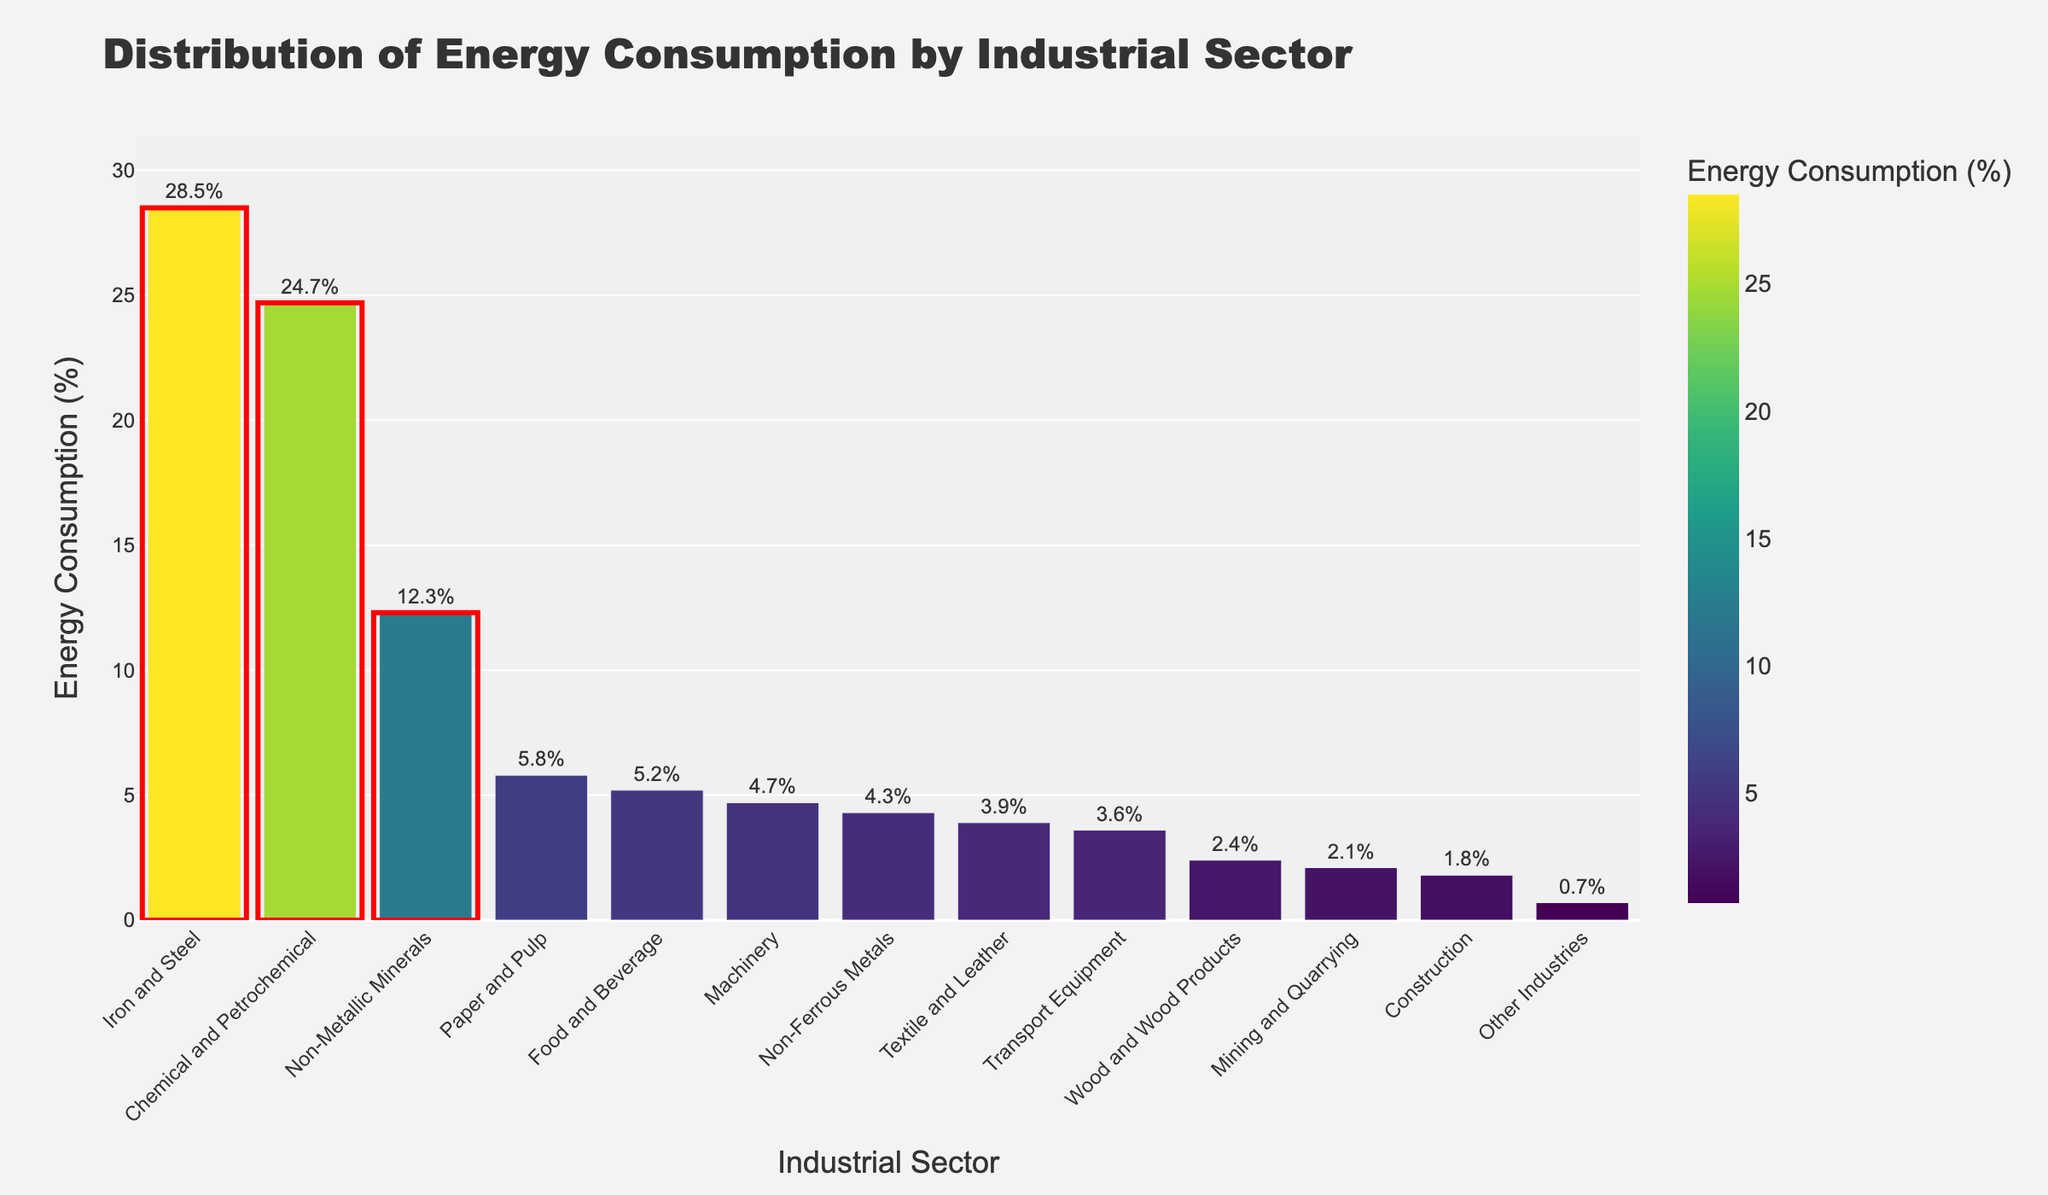What sector has the highest energy consumption? The figure highlights sectors in different colors and shows their energy consumption as percentages. The sector with the tallest bar and highest percentage is the Iron and Steel sector.
Answer: Iron and Steel What is the combined energy consumption percentage of the top three sectors? The top three sectors by energy consumption percentage are Iron and Steel (28.5%), Chemical and Petrochemical (24.7%), and Non-Metallic Minerals (12.3%). Adding these percentages gives their combined energy consumption: 28.5 + 24.7 + 12.3 = 65.5%.
Answer: 65.5% How does the energy consumption of the Food and Beverage sector compare to that of the Paper and Pulp sector? Comparing the heights of the bars for Food and Beverage (5.2%) and Paper and Pulp (5.8%) shows that Paper and Pulp has a slightly higher energy consumption percentage than Food and Beverage.
Answer: Paper and Pulp is higher What is the energy consumption difference between Machinery and Textile and Leather sectors? Referring to the chart, the energy consumption of Machinery is 4.7% and that of Textile and Leather is 3.9%. The difference is calculated as 4.7 - 3.9 = 0.8%.
Answer: 0.8% What sector has the least energy consumption, and what is its percentage? The sector with the shortest bar and the lowest energy consumption percentage is Other Industries, with a consumption percentage of 0.7%.
Answer: Other Industries, 0.7% Which sector is highlighted with a red outline in the chart? The red outlines highlight the top three sectors with the highest energy consumption percentages: Iron and Steel, Chemical and Petrochemical, and Non-Metallic Minerals.
Answer: Iron and Steel, Chemical and Petrochemical, Non-Metallic Minerals Among the sectors with over 10% energy consumption, which sectors are included? The figure shows the energy consumption percentage for each sector. The sectors with over 10% energy consumption are Iron and Steel (28.5%), Chemical and Petrochemical (24.7%), and Non-Metallic Minerals (12.3%).
Answer: Iron and Steel, Chemical and Petrochemical, Non-Metallic Minerals How much total energy consumption is accounted for by the sectors with less than 3%? Summing the energy consumption percentages for the sectors with less than 3%: Wood and Wood Products (2.4%), Mining and Quarrying (2.1%), Construction (1.8%), and Other Industries (0.7%) results in a total of 2.4 + 2.1 + 1.8 + 0.7 = 7.0%.
Answer: 7.0% What is the average energy consumption of the top five sectors? The top five sectors and their energy consumption percentages are Iron and Steel (28.5%), Chemical and Petrochemical (24.7%), Non-Metallic Minerals (12.3%), Paper and Pulp (5.8%), and Food and Beverage (5.2%). The average is calculated as (28.5 + 24.7 + 12.3 + 5.8 + 5.2) / 5 = 15.3%.
Answer: 15.3% 